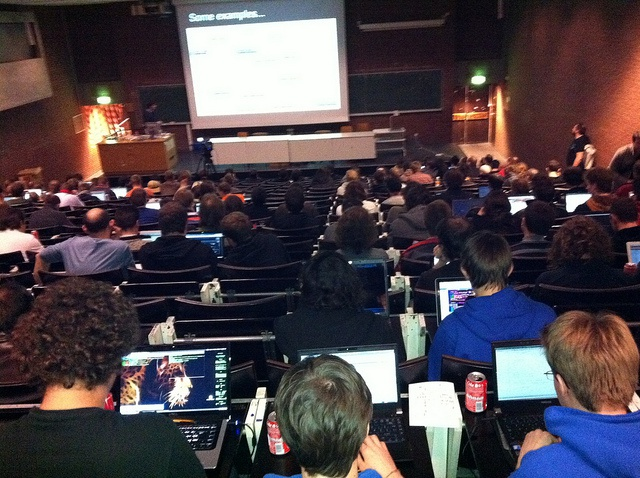Describe the objects in this image and their specific colors. I can see people in black, maroon, gray, and brown tones, people in black, maroon, gray, and tan tones, chair in black, gray, navy, and white tones, tv in black, white, pink, and gray tones, and people in black, blue, brown, and maroon tones in this image. 